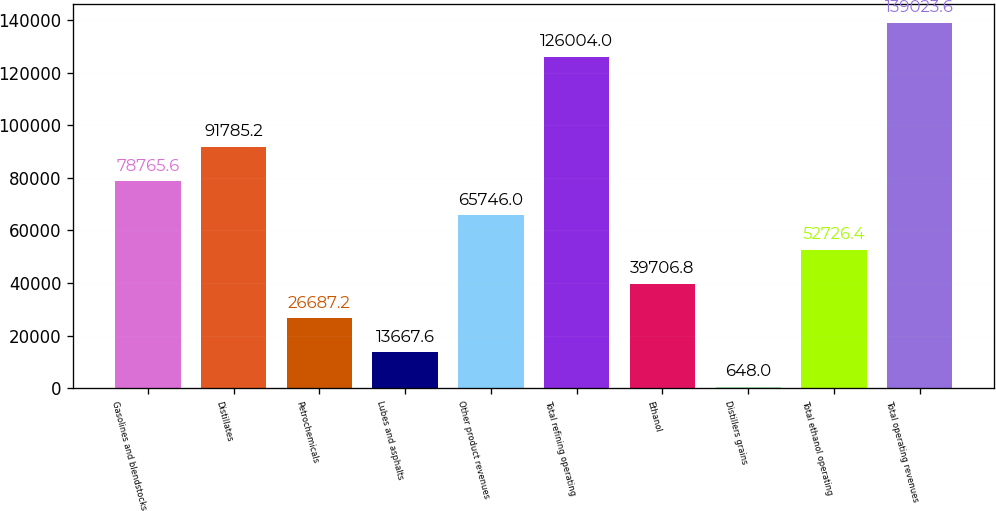<chart> <loc_0><loc_0><loc_500><loc_500><bar_chart><fcel>Gasolines and blendstocks<fcel>Distillates<fcel>Petrochemicals<fcel>Lubes and asphalts<fcel>Other product revenues<fcel>Total refining operating<fcel>Ethanol<fcel>Distillers grains<fcel>Total ethanol operating<fcel>Total operating revenues<nl><fcel>78765.6<fcel>91785.2<fcel>26687.2<fcel>13667.6<fcel>65746<fcel>126004<fcel>39706.8<fcel>648<fcel>52726.4<fcel>139024<nl></chart> 